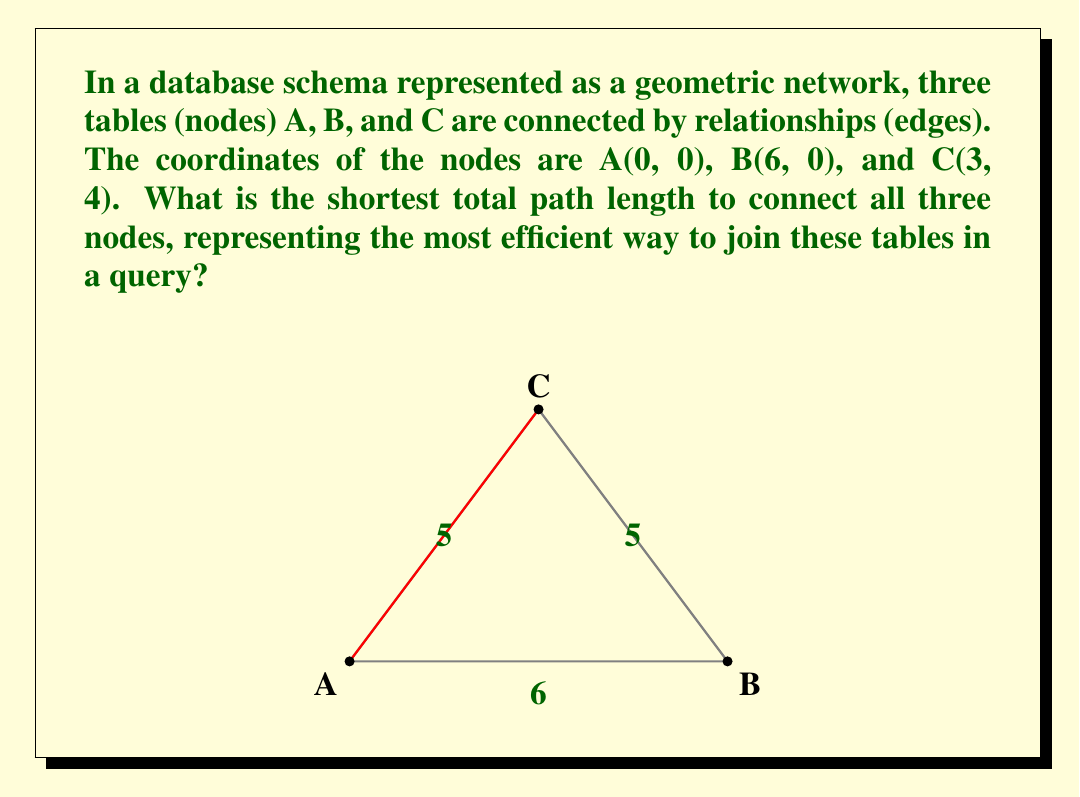What is the answer to this math problem? To solve this problem, we need to find the minimum spanning tree of the geometric network. Here's the step-by-step solution:

1) First, calculate the distances between each pair of nodes using the distance formula:
   $d = \sqrt{(x_2-x_1)^2 + (y_2-y_1)^2}$

   AB: $\sqrt{(6-0)^2 + (0-0)^2} = 6$
   AC: $\sqrt{(3-0)^2 + (4-0)^2} = 5$
   BC: $\sqrt{(3-6)^2 + (4-0)^2} = 5$

2) The shortest path will be the one that connects all nodes with the minimum total length. This is equivalent to finding the minimum spanning tree.

3) To find the minimum spanning tree, we can use Kruskal's algorithm:
   - Sort the edges by length: AC (5), BC (5), AB (6)
   - Start with the shortest edge: AC
   - Add the next shortest edge that doesn't create a cycle: BC

4) The minimum spanning tree consists of edges AC and BC, both with length 5.

5) The total length of the shortest path is therefore:
   $5 + 5 = 10$

This represents the most efficient way to join these tables in a query, minimizing the "distance" (which could represent computational cost or data transfer) between the tables.
Answer: 10 units 